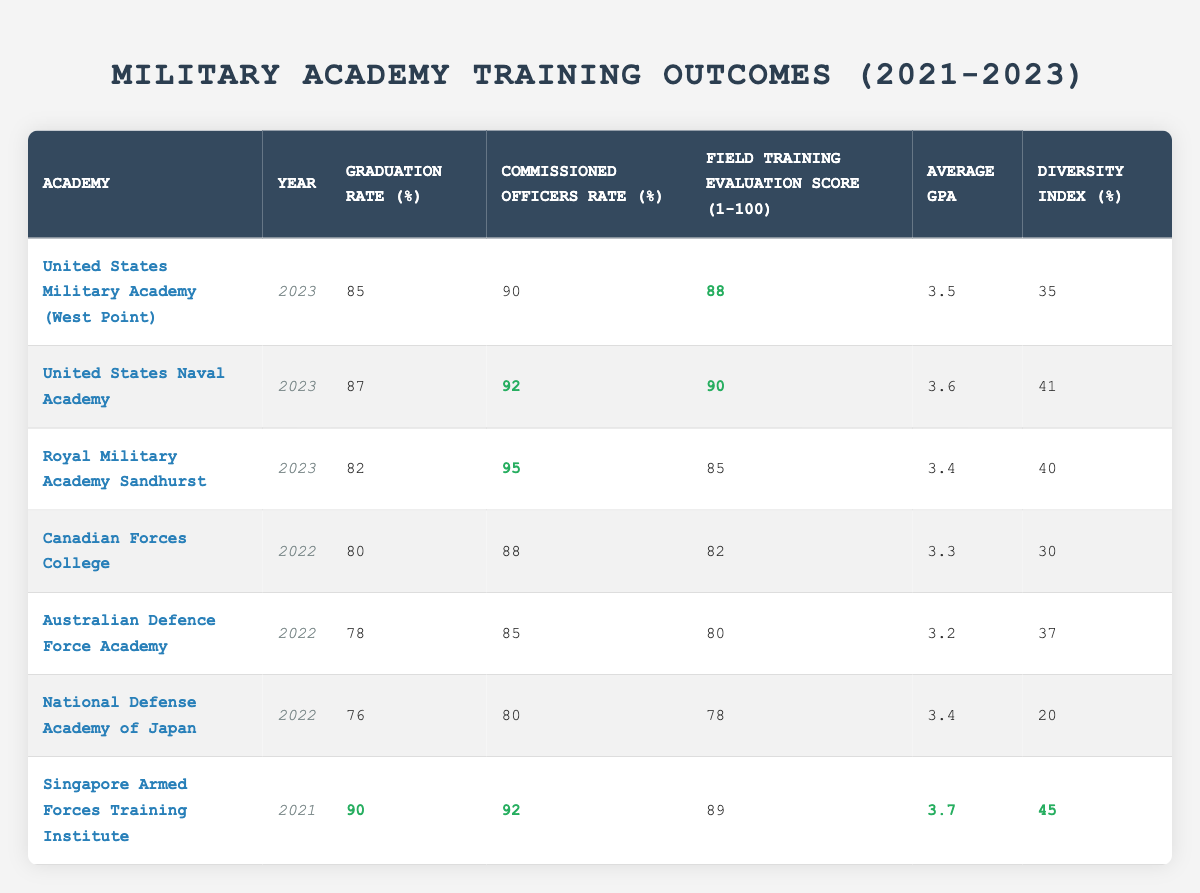What is the graduation rate of the United States Naval Academy in 2023? The table lists the United States Naval Academy's graduation rate for the year 2023 in the respective column, which is 87%.
Answer: 87% Which academy had the highest field training evaluation score in 2023? By comparing the Field Training Evaluation Scores for all academies listed for 2023, the United States Naval Academy has the highest score of 90.
Answer: United States Naval Academy What is the average graduation rate for the years listed in the table? To find the average graduation rate, sum the graduation rates: (85 + 87 + 82 + 80 + 78 + 76 + 90) = 578. There are 7 data points, so the average is 578/7 = 82.57, which rounds to about 82.57%.
Answer: 82.57% Did the Royal Military Academy Sandhurst have a higher commissioned officer rate than the Canadian Forces College in 2022? The Royal Military Academy Sandhurst has a commissioned officer rate of 95% and the Canadian Forces College has a rate of 88%. Since 95% is greater than 88%, the statement is true.
Answer: Yes Which academy had the lowest diversity index among those listed in 2022? The National Defense Academy of Japan had a diversity index of 20%, which is lower than that of all other academies listed for that year (30% for Canadian Forces College and 37% for Australian Defence Force Academy).
Answer: National Defense Academy of Japan Of the academies listed for 2023, which one had the lowest average GPA? The average GPAs can be compared for the academies listed in 2023: West Point (3.5), U.S. Naval Academy (3.6), and Royal Military Academy Sandhurst (3.4). The lowest GPA is from the Royal Military Academy Sandhurst at 3.4.
Answer: Royal Military Academy Sandhurst What was the difference in the graduation rates between the Singapore Armed Forces Training Institute in 2021 and the National Defense Academy of Japan in 2022? The graduation rate for Singapore Armed Forces Training Institute in 2021 is 90% and for National Defense Academy of Japan in 2022 is 76%. The difference is calculated as 90 - 76 = 14%.
Answer: 14% How many academies had a commissioned officer rate of over 90% in 2023? In 2023, the United States Naval Academy (92%) and Royal Military Academy Sandhurst (95%) had commissioned officer rates over 90%, resulting in a total of 2 academies.
Answer: 2 What is the highest average GPA recorded among the listed academies, and which academy achieved it? By examining the average GPAs, Singapore Armed Forces Training Institute has the highest at 3.7. Therefore, it has the highest GPA.
Answer: 3.7, Singapore Armed Forces Training Institute 